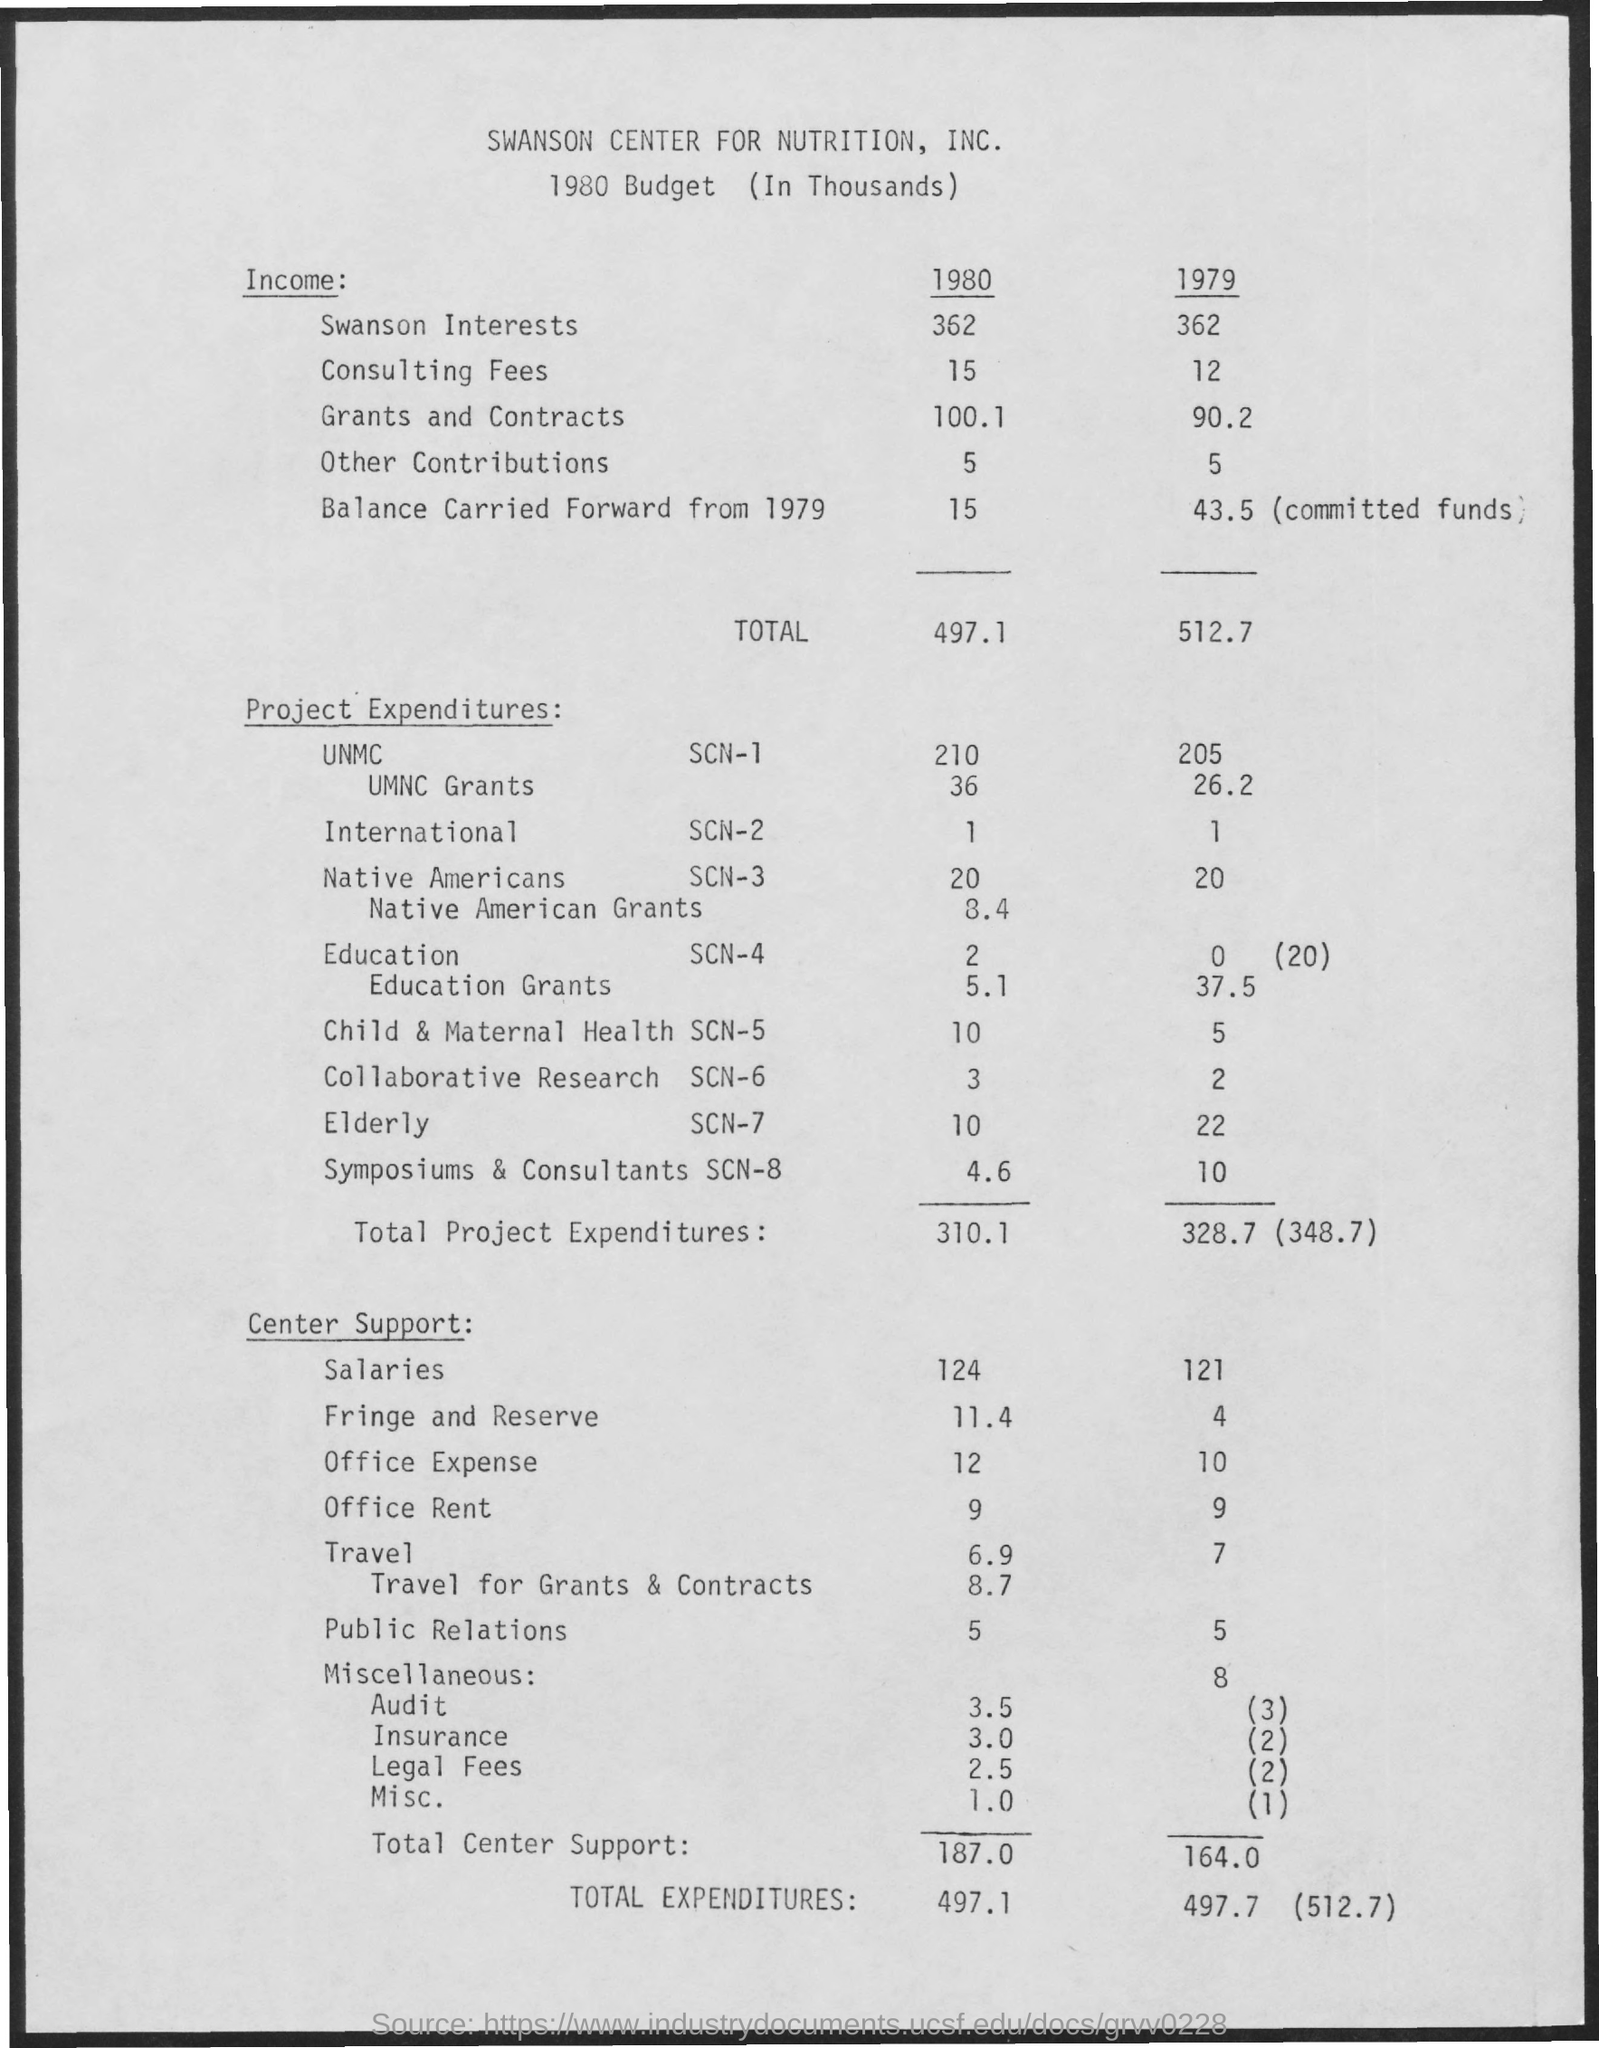Specify some key components in this picture. The total expenditures for the project in the year 1980 was 310.1. In 1979, the income value of consulting fees was X. The value of other contributions in the year 1979 is currently unknown. The value of total center support for the year 1979 was 164.0. The total expenditures for the project in the year 1979 were $328.7 million. 